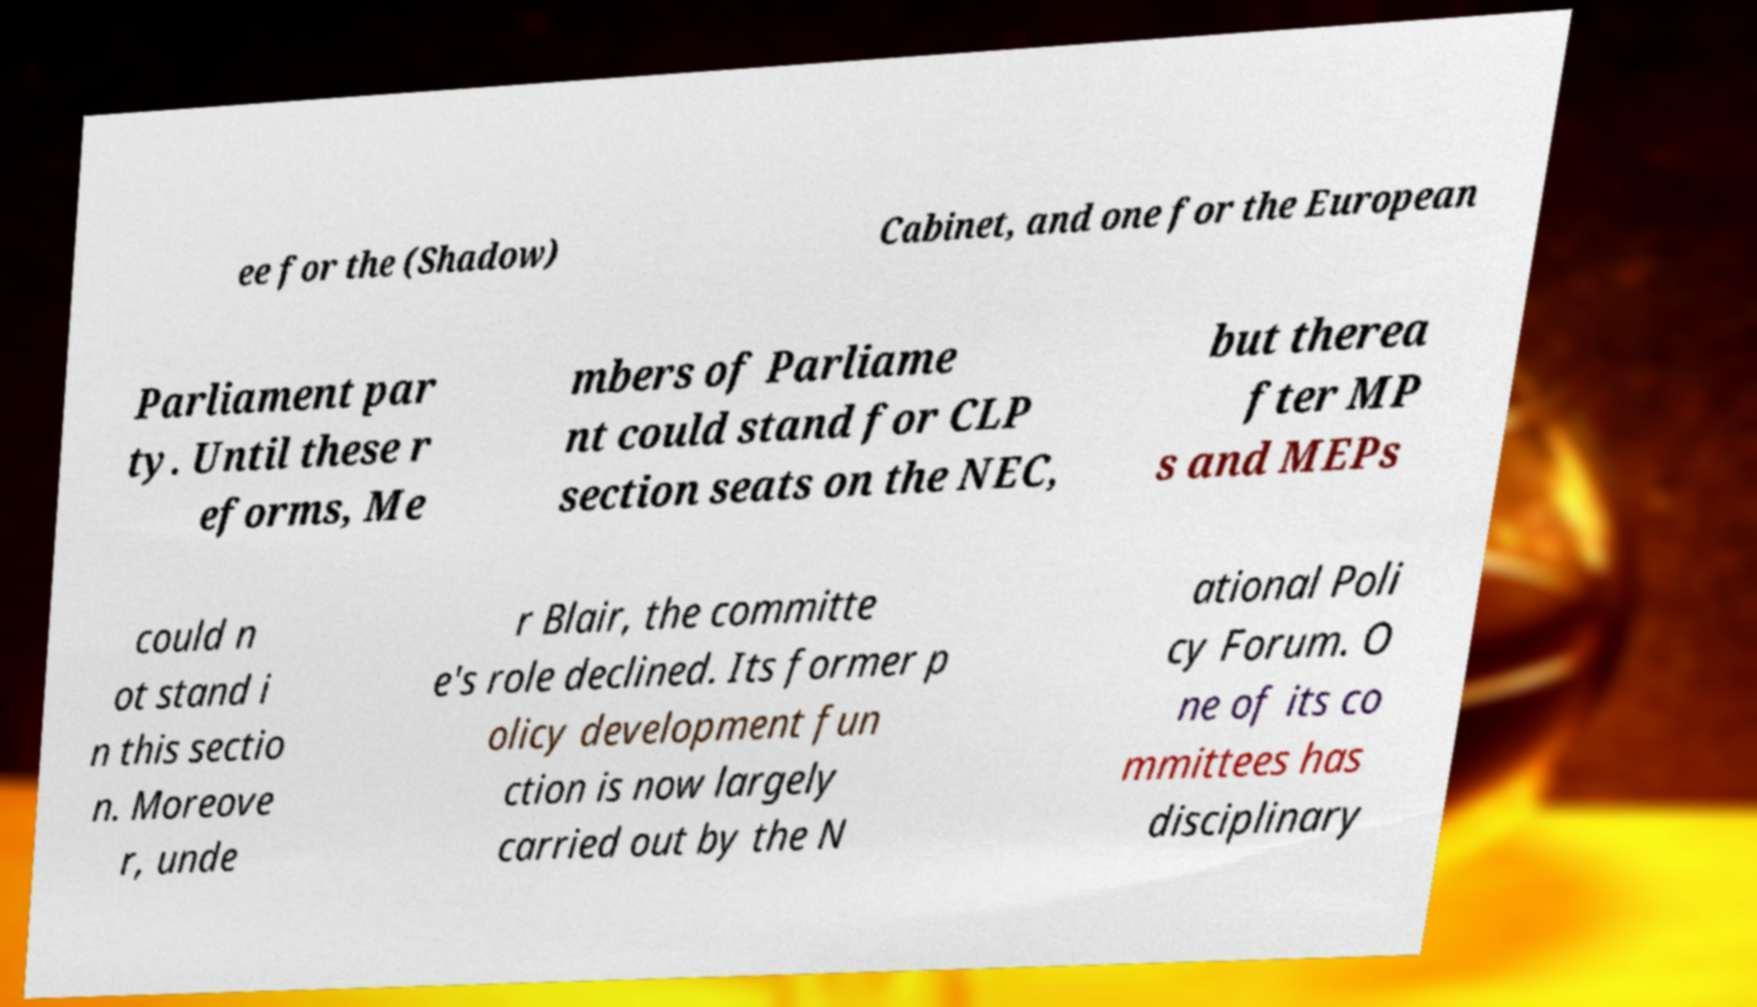For documentation purposes, I need the text within this image transcribed. Could you provide that? ee for the (Shadow) Cabinet, and one for the European Parliament par ty. Until these r eforms, Me mbers of Parliame nt could stand for CLP section seats on the NEC, but therea fter MP s and MEPs could n ot stand i n this sectio n. Moreove r, unde r Blair, the committe e's role declined. Its former p olicy development fun ction is now largely carried out by the N ational Poli cy Forum. O ne of its co mmittees has disciplinary 